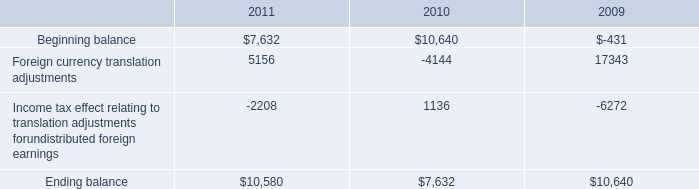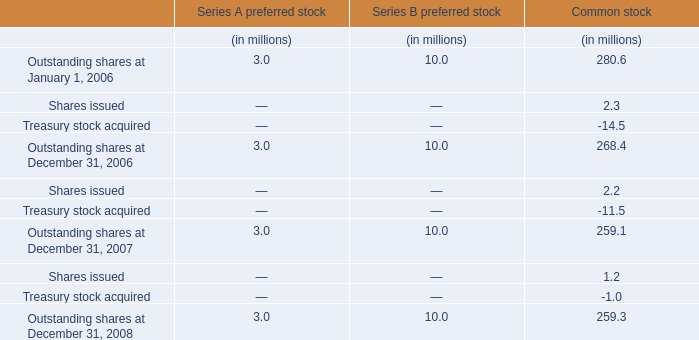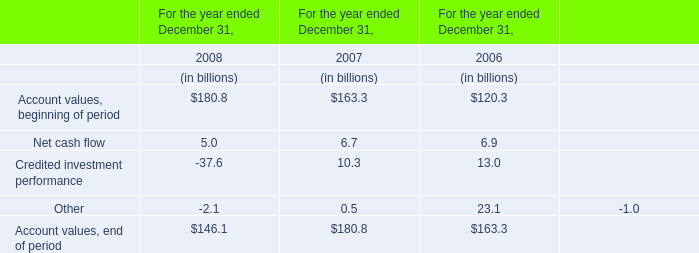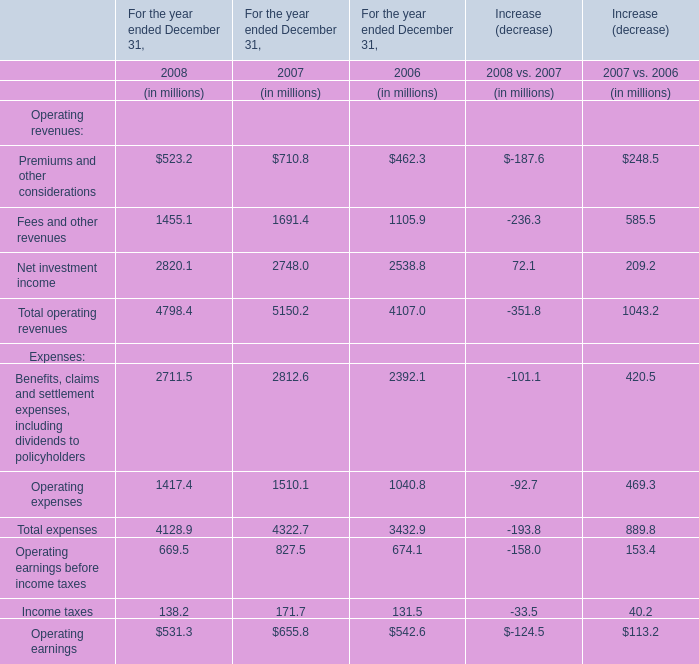what is the growth rate in the average price of repurchased shares from 2010 to 2011? 
Computations: ((31.81 - 29.19) / 29.19)
Answer: 0.08976. 